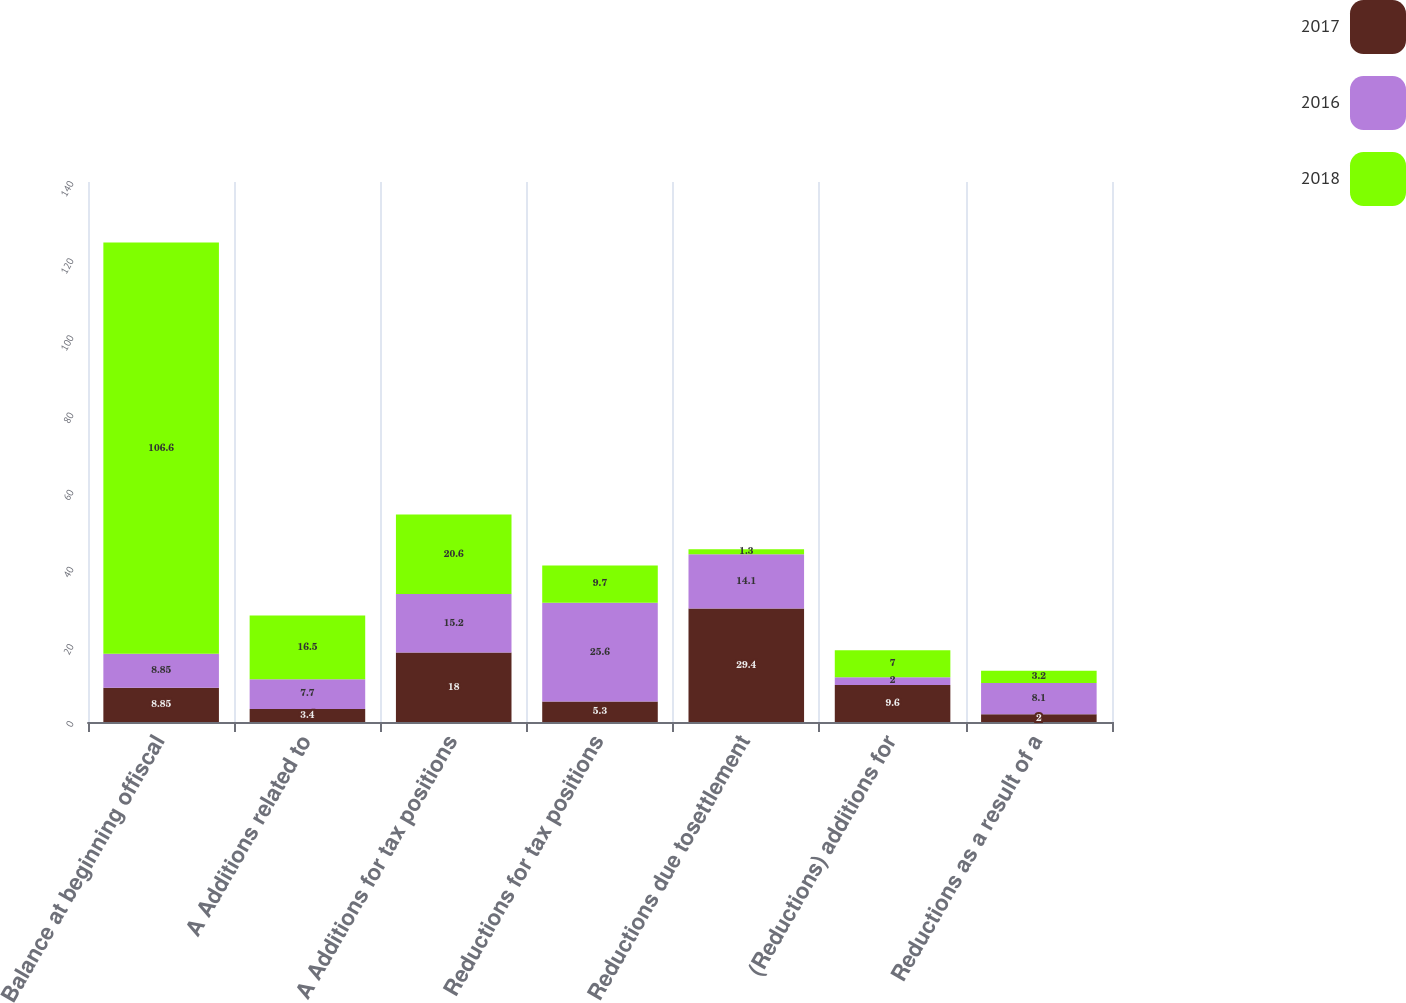<chart> <loc_0><loc_0><loc_500><loc_500><stacked_bar_chart><ecel><fcel>Balance at beginning offiscal<fcel>A Additions related to<fcel>A Additions for tax positions<fcel>Reductions for tax positions<fcel>Reductions due tosettlement<fcel>(Reductions) additions for<fcel>Reductions as a result of a<nl><fcel>2017<fcel>8.85<fcel>3.4<fcel>18<fcel>5.3<fcel>29.4<fcel>9.6<fcel>2<nl><fcel>2016<fcel>8.85<fcel>7.7<fcel>15.2<fcel>25.6<fcel>14.1<fcel>2<fcel>8.1<nl><fcel>2018<fcel>106.6<fcel>16.5<fcel>20.6<fcel>9.7<fcel>1.3<fcel>7<fcel>3.2<nl></chart> 